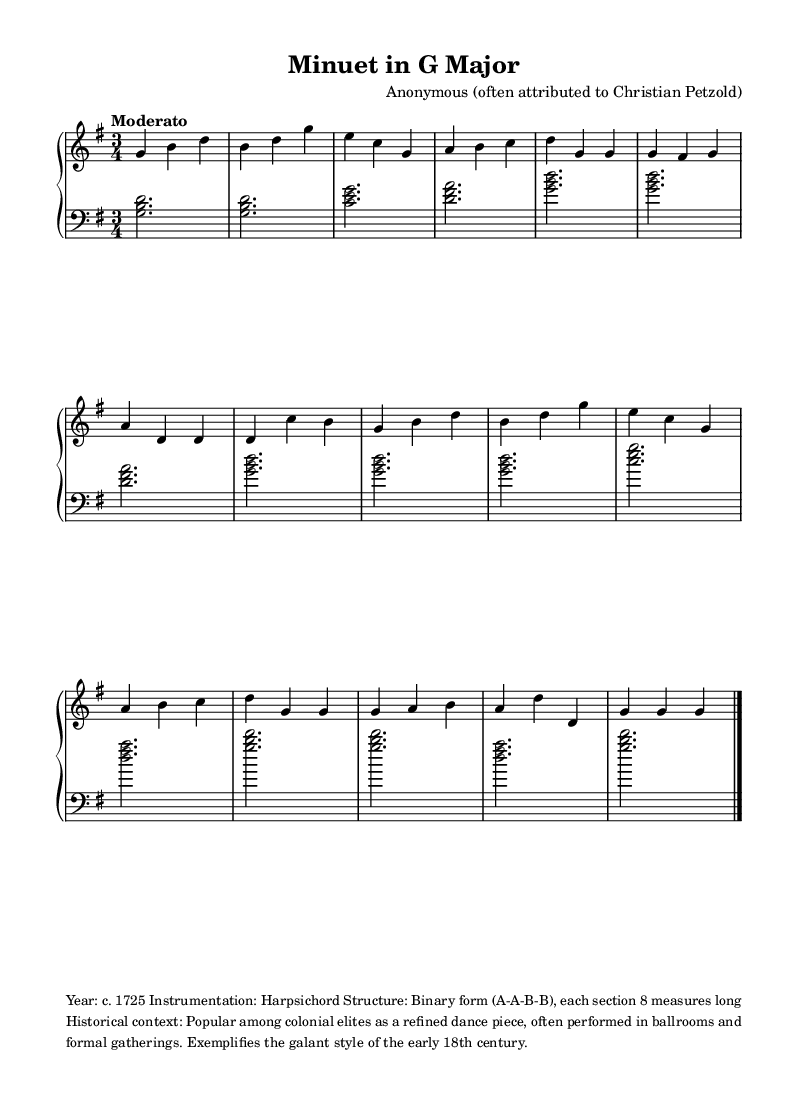What is the key signature of this music? The key signature is G major, which has one sharp (F#).
Answer: G major What is the time signature of this piece? The time signature is 3/4, indicating three beats per measure with a quarter note receiving one beat.
Answer: 3/4 What is the tempo marking for this composition? The tempo marking is "Moderato," which suggests a moderate speed for the piece.
Answer: Moderato How many measures are in each section of the music? Each section of the music has 8 measures, as indicated by the binary form structure (A-A-B-B).
Answer: 8 measures What are the first three notes of the melody? The first three notes of the melody are G, B, and D, which are outlined in the first measure.
Answer: G, B, D What mechanism in dance does this piece exemplify? This piece exemplifies the galant style, which reflects elegant and graceful musical expression typical of the early 18th century.
Answer: Galant style What is the instrumentation for this composition? The instrumentation for this composition is the harpsichord, which was a popular keyboard instrument in the early 18th century.
Answer: Harpsichord 